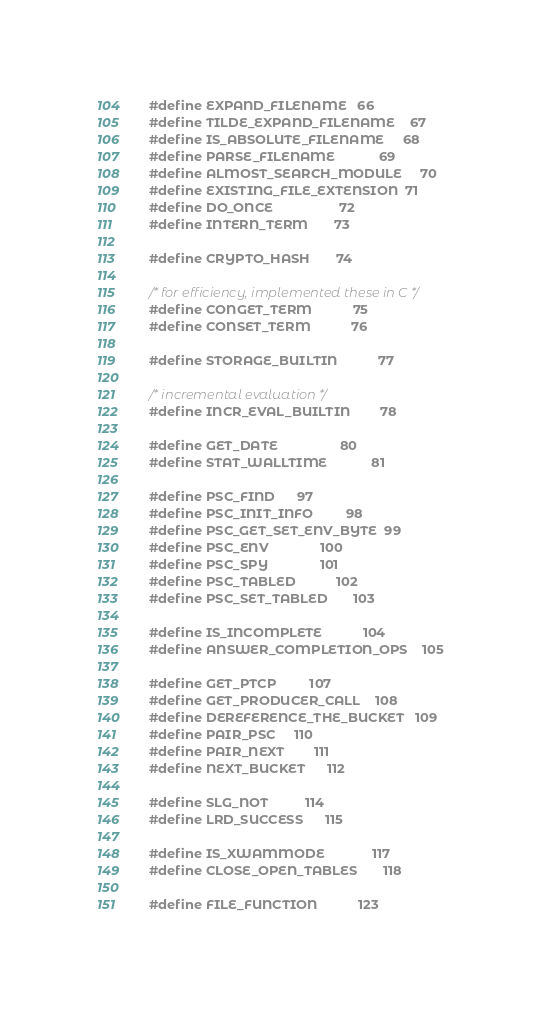<code> <loc_0><loc_0><loc_500><loc_500><_C_>#define EXPAND_FILENAME 	 66
#define TILDE_EXPAND_FILENAME    67
#define IS_ABSOLUTE_FILENAME     68
#define PARSE_FILENAME        	 69
#define ALMOST_SEARCH_MODULE     70
#define EXISTING_FILE_EXTENSION  71
#define DO_ONCE                  72
#define INTERN_TERM		 73

#define CRYPTO_HASH		 74

/* for efficiency, implemented these in C */
#define CONGET_TERM	         75
#define CONSET_TERM	         76

#define STORAGE_BUILTIN	       	 77

/* incremental evaluation */
#define INCR_EVAL_BUILTIN        78

#define GET_DATE                 80
#define STAT_WALLTIME            81

#define PSC_FIND		 97
#define PSC_INIT_INFO		 98
#define PSC_GET_SET_ENV_BYTE	 99
#define PSC_ENV		        100
#define PSC_SPY		        101
#define PSC_TABLED	        102
#define PSC_SET_TABLED		103

#define IS_INCOMPLETE           104
#define ANSWER_COMPLETION_OPS	105

#define GET_PTCP	        107
#define GET_PRODUCER_CALL	108
#define DEREFERENCE_THE_BUCKET	109
#define PAIR_PSC		110
#define PAIR_NEXT		111
#define NEXT_BUCKET		112

#define SLG_NOT			114
#define LRD_SUCCESS		115

#define IS_XWAMMODE             117
#define CLOSE_OPEN_TABLES       118

#define FILE_FUNCTION           123</code> 